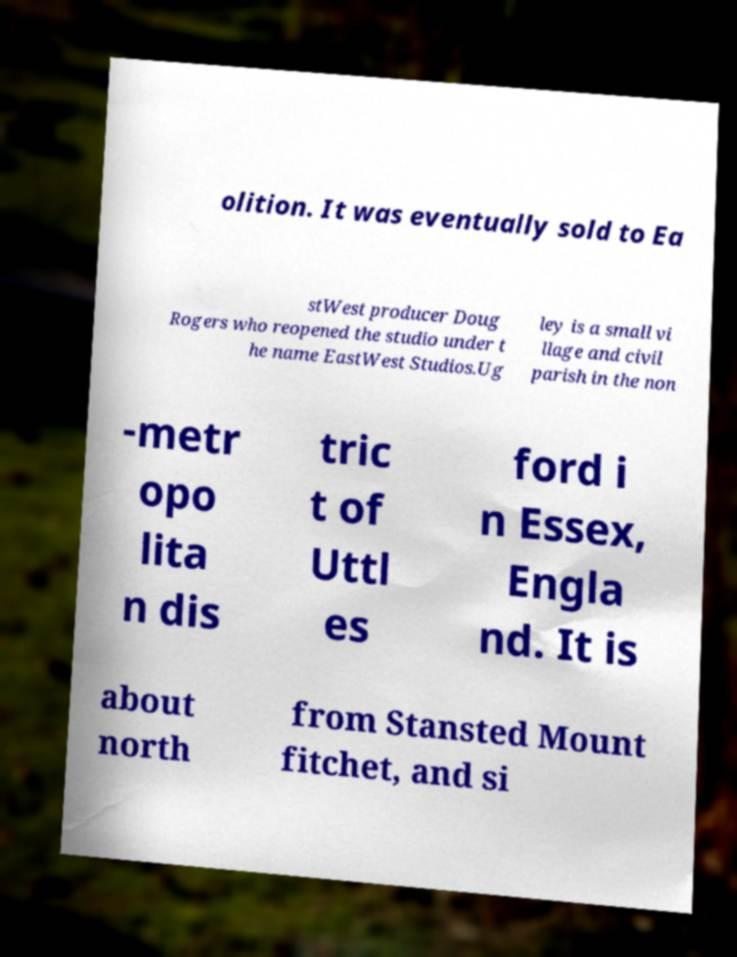Could you assist in decoding the text presented in this image and type it out clearly? olition. It was eventually sold to Ea stWest producer Doug Rogers who reopened the studio under t he name EastWest Studios.Ug ley is a small vi llage and civil parish in the non -metr opo lita n dis tric t of Uttl es ford i n Essex, Engla nd. It is about north from Stansted Mount fitchet, and si 